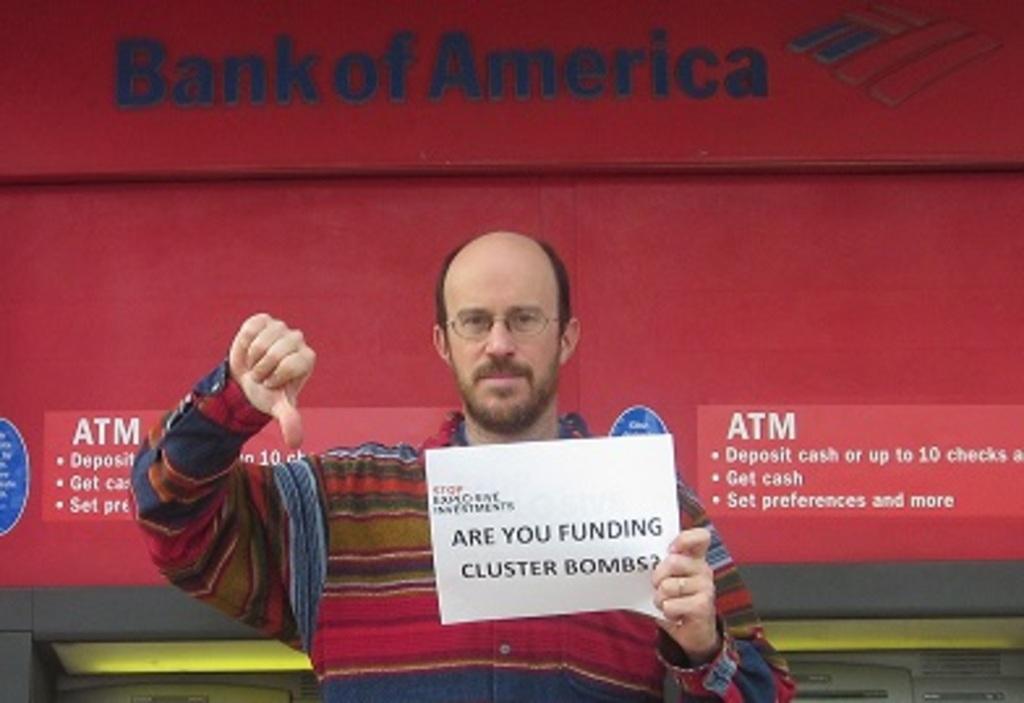In one or two sentences, can you explain what this image depicts? In the center of this picture we can see a man wearing shirt, holding a paper and seems to be standing and we can see the text on the paper. In the background we can see the text on the banners and we can see some the other objects. 